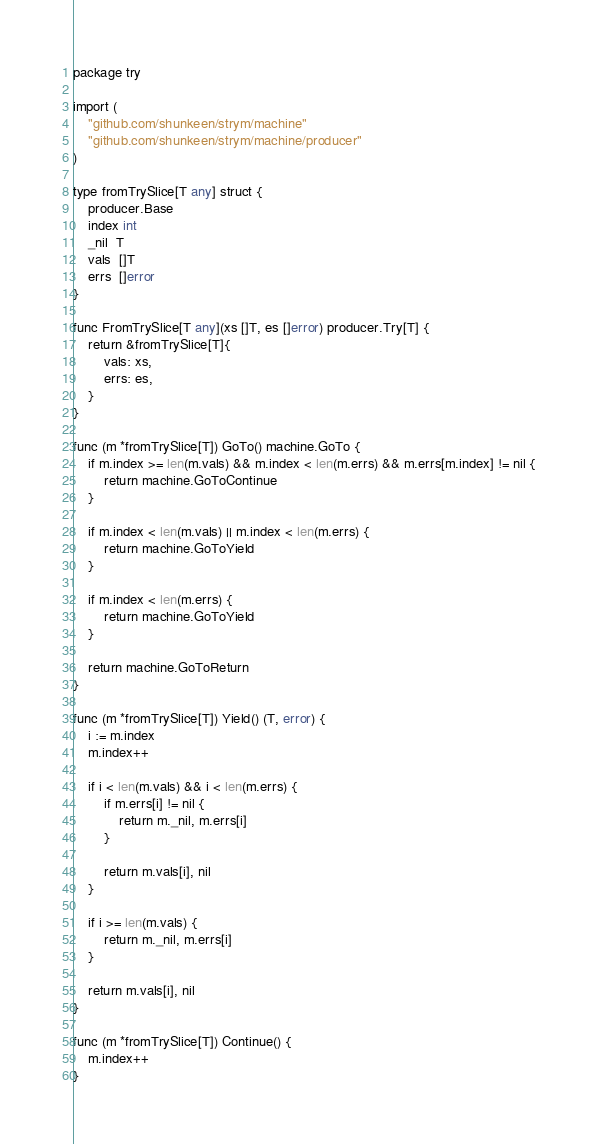<code> <loc_0><loc_0><loc_500><loc_500><_Go_>package try

import (
	"github.com/shunkeen/strym/machine"
	"github.com/shunkeen/strym/machine/producer"
)

type fromTrySlice[T any] struct {
	producer.Base
	index int
	_nil  T
	vals  []T
	errs  []error
}

func FromTrySlice[T any](xs []T, es []error) producer.Try[T] {
	return &fromTrySlice[T]{
		vals: xs,
		errs: es,
	}
}

func (m *fromTrySlice[T]) GoTo() machine.GoTo {
	if m.index >= len(m.vals) && m.index < len(m.errs) && m.errs[m.index] != nil {
		return machine.GoToContinue
	}

	if m.index < len(m.vals) || m.index < len(m.errs) {
		return machine.GoToYield
	}

	if m.index < len(m.errs) {
		return machine.GoToYield
	}

	return machine.GoToReturn
}

func (m *fromTrySlice[T]) Yield() (T, error) {
	i := m.index
	m.index++

	if i < len(m.vals) && i < len(m.errs) {
		if m.errs[i] != nil {
			return m._nil, m.errs[i]
		}

		return m.vals[i], nil
	}

	if i >= len(m.vals) {
		return m._nil, m.errs[i]
	}

	return m.vals[i], nil
}

func (m *fromTrySlice[T]) Continue() {
	m.index++
}
</code> 